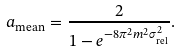Convert formula to latex. <formula><loc_0><loc_0><loc_500><loc_500>a _ { \text {mean} } = \frac { 2 } { 1 - e ^ { - 8 \pi ^ { 2 } m ^ { 2 } \sigma _ { \text {rel} } ^ { 2 } } } .</formula> 